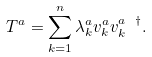<formula> <loc_0><loc_0><loc_500><loc_500>T ^ { a } = \sum _ { k = 1 } ^ { n } \lambda _ { k } ^ { a } v _ { k } ^ { a } v _ { k } ^ { a \ \dagger } .</formula> 